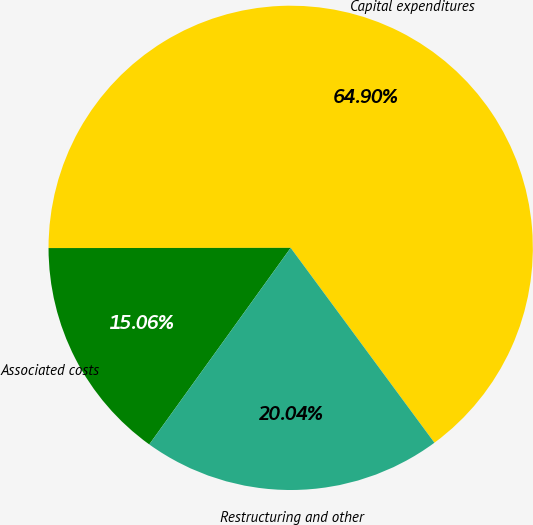Convert chart. <chart><loc_0><loc_0><loc_500><loc_500><pie_chart><fcel>Capital expenditures<fcel>Associated costs<fcel>Restructuring and other<nl><fcel>64.9%<fcel>15.06%<fcel>20.04%<nl></chart> 